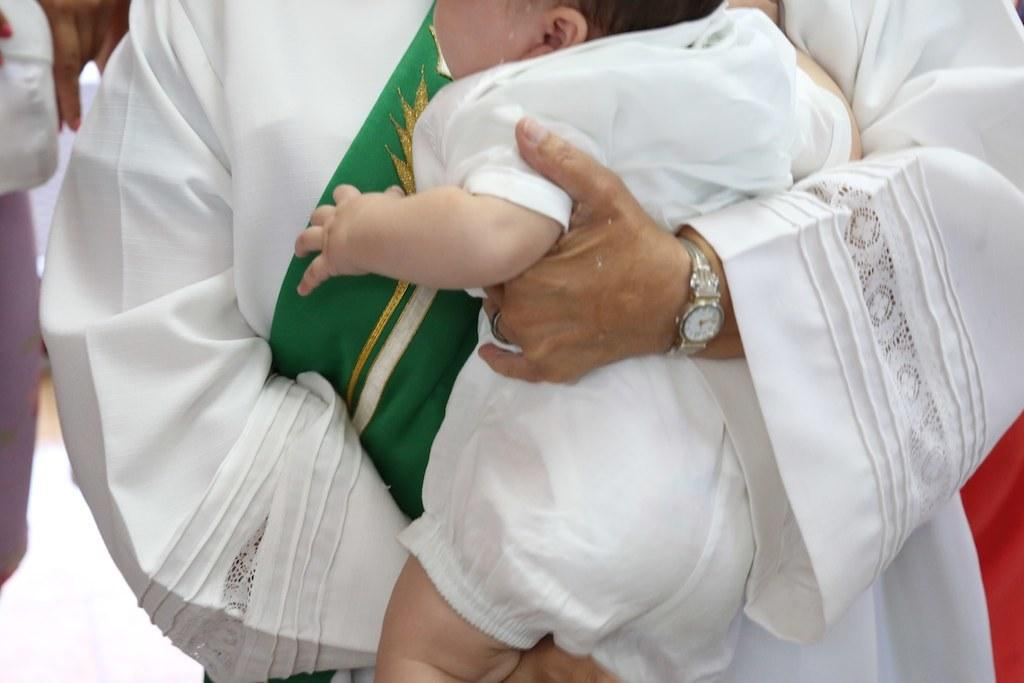What is the person in the image wearing? The person in the image is wearing white clothes. Can you describe any accessories the person is wearing? The person is wearing a watch. What is the person holding in the image? The person is holding a baby. Is there anyone else visible in the image? Yes, there is another person on the left side of the image. What type of berry is the person eating in the image? There is no berry present in the image; the person is holding a baby. Is the person wearing a crown in the image? No, the person is not wearing a crown in the image; they are wearing white clothes. 